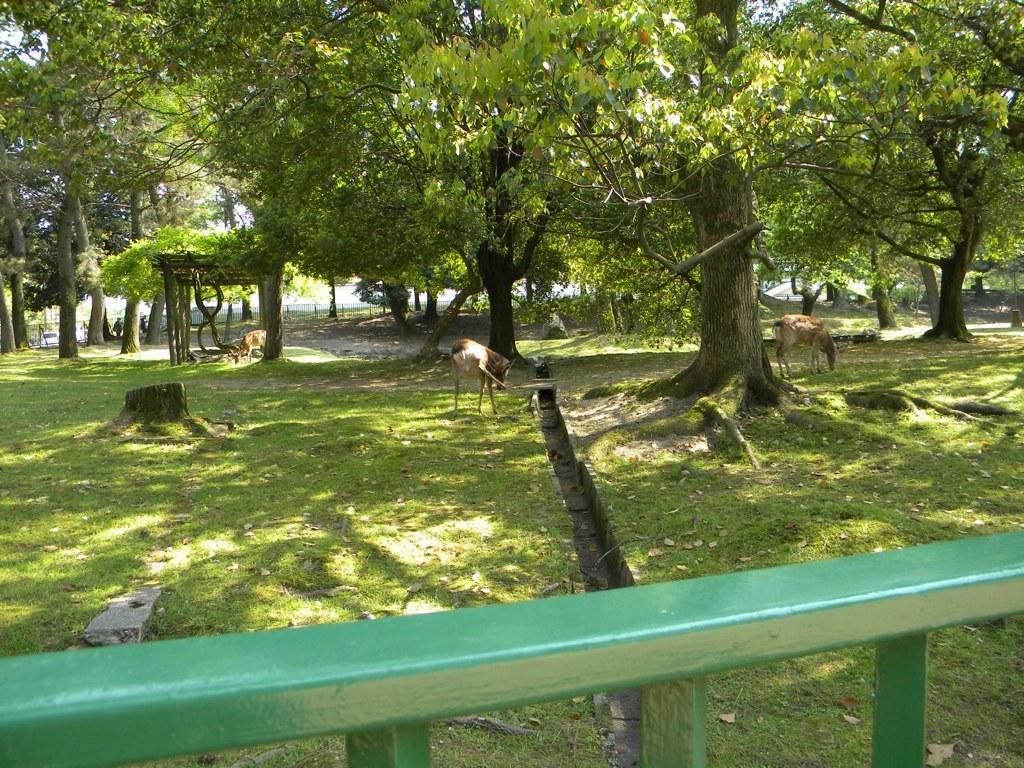In one or two sentences, can you explain what this image depicts? In this image i can see trees ,under the trees I can see animals,at the bottom I can see green color rod. 